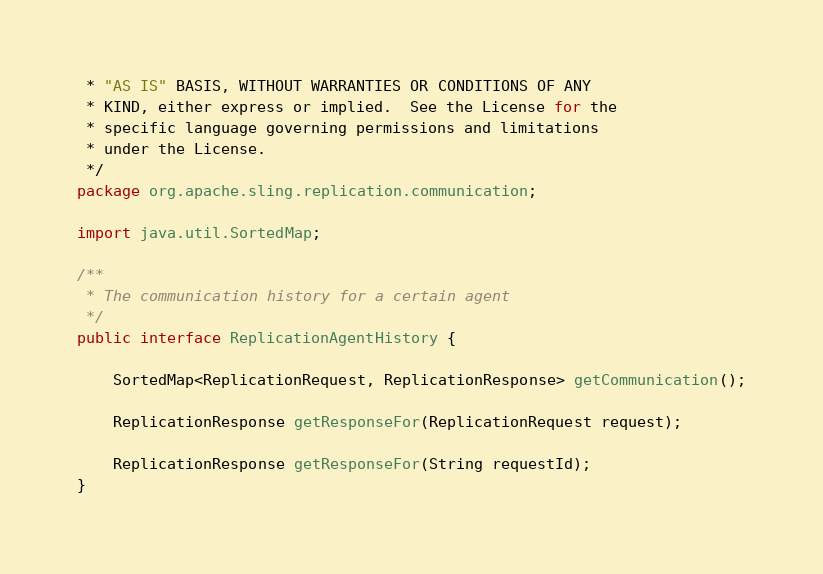Convert code to text. <code><loc_0><loc_0><loc_500><loc_500><_Java_> * "AS IS" BASIS, WITHOUT WARRANTIES OR CONDITIONS OF ANY
 * KIND, either express or implied.  See the License for the
 * specific language governing permissions and limitations
 * under the License.
 */
package org.apache.sling.replication.communication;

import java.util.SortedMap;

/**
 * The communication history for a certain agent
 */
public interface ReplicationAgentHistory {

    SortedMap<ReplicationRequest, ReplicationResponse> getCommunication();

    ReplicationResponse getResponseFor(ReplicationRequest request);

    ReplicationResponse getResponseFor(String requestId);
}
</code> 